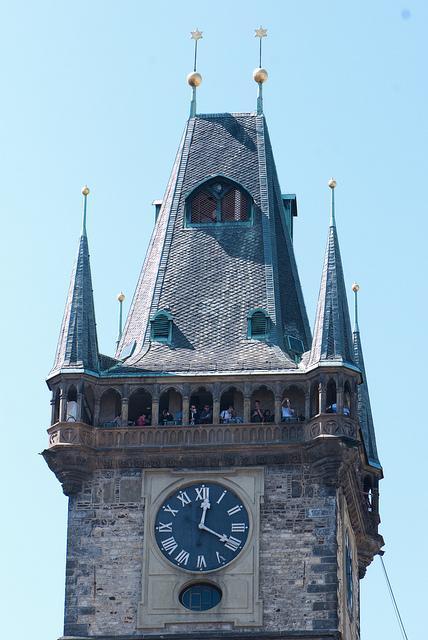How many umbrellas are there?
Give a very brief answer. 0. 